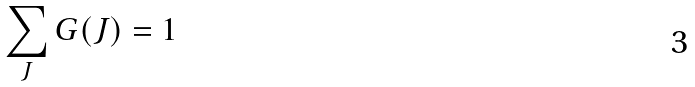<formula> <loc_0><loc_0><loc_500><loc_500>\sum _ { J } { G ( J ) } = 1</formula> 